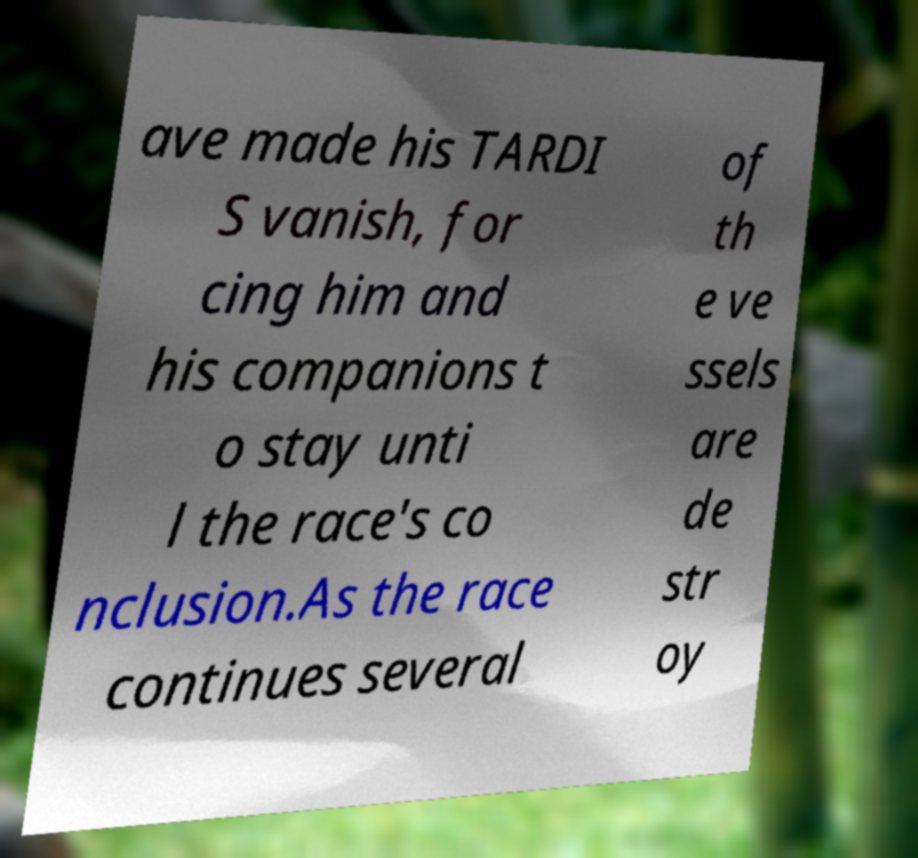Could you assist in decoding the text presented in this image and type it out clearly? ave made his TARDI S vanish, for cing him and his companions t o stay unti l the race's co nclusion.As the race continues several of th e ve ssels are de str oy 